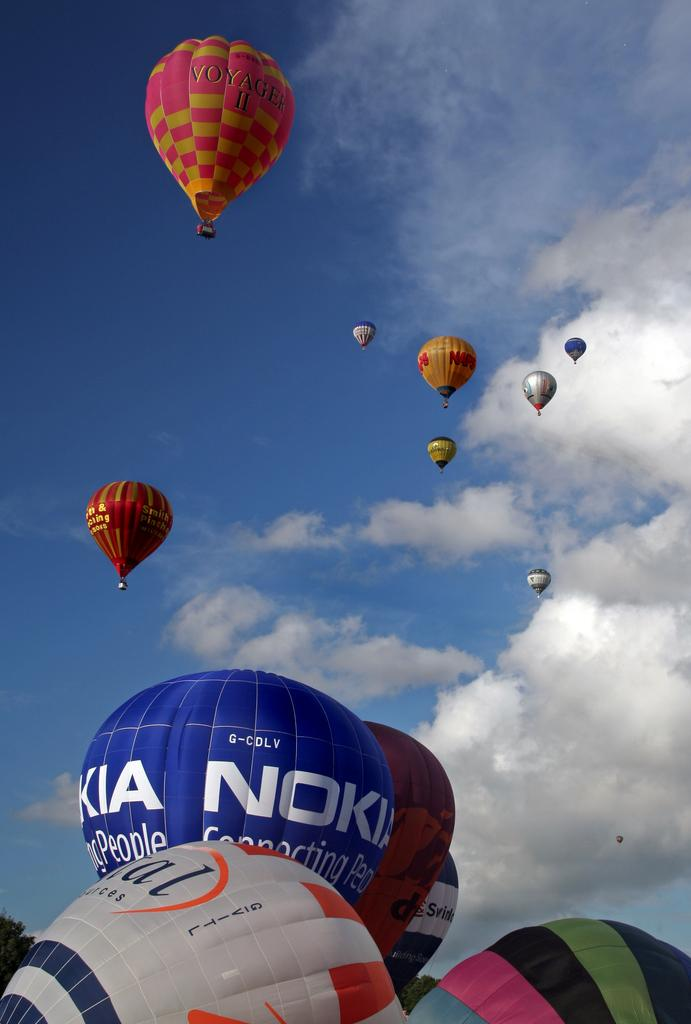What is the main subject of the image? The main subject of the image is hot air balloons. What can be seen in the sky in the image? There are clouds in the sky in the image. What type of truck is visible in the image? There is no truck present in the image; it features hot air balloons and clouds in the sky. What time of day is it in the image, based on the size of the hot air balloons? The size of the hot air balloons cannot be used to determine the time of day in the image. 